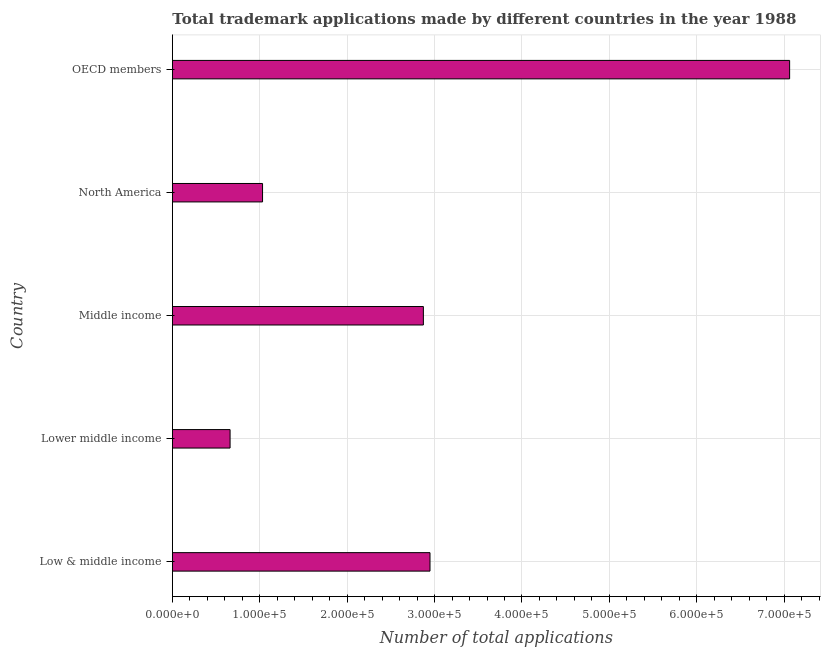What is the title of the graph?
Your response must be concise. Total trademark applications made by different countries in the year 1988. What is the label or title of the X-axis?
Make the answer very short. Number of total applications. What is the label or title of the Y-axis?
Your answer should be compact. Country. What is the number of trademark applications in Middle income?
Offer a terse response. 2.87e+05. Across all countries, what is the maximum number of trademark applications?
Ensure brevity in your answer.  7.06e+05. Across all countries, what is the minimum number of trademark applications?
Provide a succinct answer. 6.60e+04. In which country was the number of trademark applications maximum?
Provide a succinct answer. OECD members. In which country was the number of trademark applications minimum?
Provide a short and direct response. Lower middle income. What is the sum of the number of trademark applications?
Make the answer very short. 1.46e+06. What is the difference between the number of trademark applications in Lower middle income and OECD members?
Offer a terse response. -6.40e+05. What is the average number of trademark applications per country?
Give a very brief answer. 2.91e+05. What is the median number of trademark applications?
Ensure brevity in your answer.  2.87e+05. In how many countries, is the number of trademark applications greater than 620000 ?
Make the answer very short. 1. What is the ratio of the number of trademark applications in Low & middle income to that in OECD members?
Provide a short and direct response. 0.42. Is the number of trademark applications in North America less than that in OECD members?
Offer a terse response. Yes. What is the difference between the highest and the second highest number of trademark applications?
Ensure brevity in your answer.  4.11e+05. What is the difference between the highest and the lowest number of trademark applications?
Offer a very short reply. 6.40e+05. Are the values on the major ticks of X-axis written in scientific E-notation?
Give a very brief answer. Yes. What is the Number of total applications of Low & middle income?
Ensure brevity in your answer.  2.95e+05. What is the Number of total applications of Lower middle income?
Your response must be concise. 6.60e+04. What is the Number of total applications in Middle income?
Offer a terse response. 2.87e+05. What is the Number of total applications in North America?
Provide a short and direct response. 1.03e+05. What is the Number of total applications in OECD members?
Provide a succinct answer. 7.06e+05. What is the difference between the Number of total applications in Low & middle income and Lower middle income?
Provide a short and direct response. 2.29e+05. What is the difference between the Number of total applications in Low & middle income and Middle income?
Your answer should be compact. 7587. What is the difference between the Number of total applications in Low & middle income and North America?
Provide a succinct answer. 1.92e+05. What is the difference between the Number of total applications in Low & middle income and OECD members?
Keep it short and to the point. -4.11e+05. What is the difference between the Number of total applications in Lower middle income and Middle income?
Keep it short and to the point. -2.21e+05. What is the difference between the Number of total applications in Lower middle income and North America?
Your answer should be very brief. -3.72e+04. What is the difference between the Number of total applications in Lower middle income and OECD members?
Your answer should be compact. -6.40e+05. What is the difference between the Number of total applications in Middle income and North America?
Give a very brief answer. 1.84e+05. What is the difference between the Number of total applications in Middle income and OECD members?
Your answer should be compact. -4.19e+05. What is the difference between the Number of total applications in North America and OECD members?
Make the answer very short. -6.03e+05. What is the ratio of the Number of total applications in Low & middle income to that in Lower middle income?
Provide a short and direct response. 4.46. What is the ratio of the Number of total applications in Low & middle income to that in North America?
Give a very brief answer. 2.86. What is the ratio of the Number of total applications in Low & middle income to that in OECD members?
Keep it short and to the point. 0.42. What is the ratio of the Number of total applications in Lower middle income to that in Middle income?
Give a very brief answer. 0.23. What is the ratio of the Number of total applications in Lower middle income to that in North America?
Keep it short and to the point. 0.64. What is the ratio of the Number of total applications in Lower middle income to that in OECD members?
Keep it short and to the point. 0.09. What is the ratio of the Number of total applications in Middle income to that in North America?
Offer a terse response. 2.78. What is the ratio of the Number of total applications in Middle income to that in OECD members?
Give a very brief answer. 0.41. What is the ratio of the Number of total applications in North America to that in OECD members?
Keep it short and to the point. 0.15. 